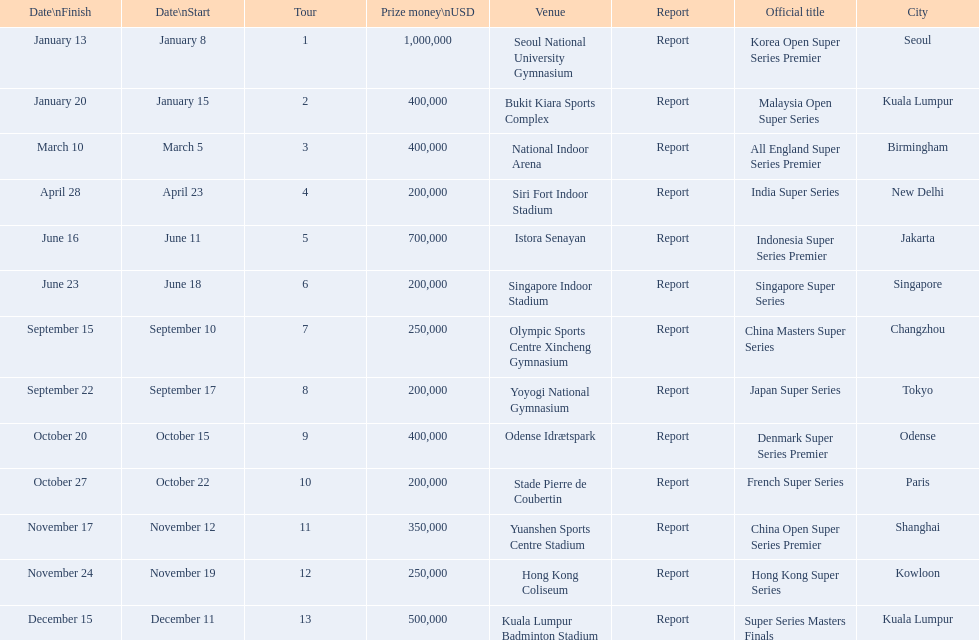What are all the titles? Korea Open Super Series Premier, Malaysia Open Super Series, All England Super Series Premier, India Super Series, Indonesia Super Series Premier, Singapore Super Series, China Masters Super Series, Japan Super Series, Denmark Super Series Premier, French Super Series, China Open Super Series Premier, Hong Kong Super Series, Super Series Masters Finals. When did they take place? January 8, January 15, March 5, April 23, June 11, June 18, September 10, September 17, October 15, October 22, November 12, November 19, December 11. Which title took place in december? Super Series Masters Finals. 